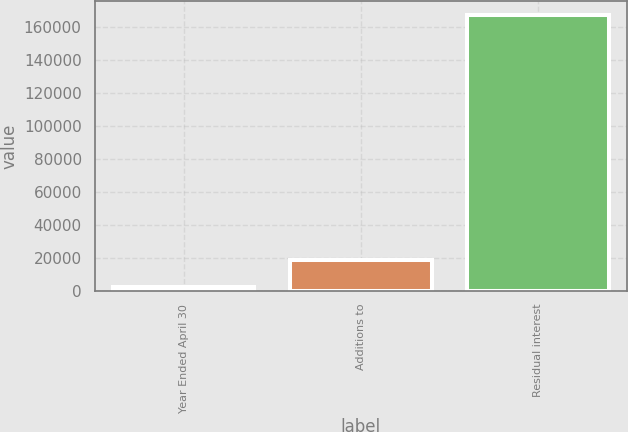Convert chart. <chart><loc_0><loc_0><loc_500><loc_500><bar_chart><fcel>Year Ended April 30<fcel>Additions to<fcel>Residual interest<nl><fcel>2004<fcel>18510.1<fcel>167065<nl></chart> 